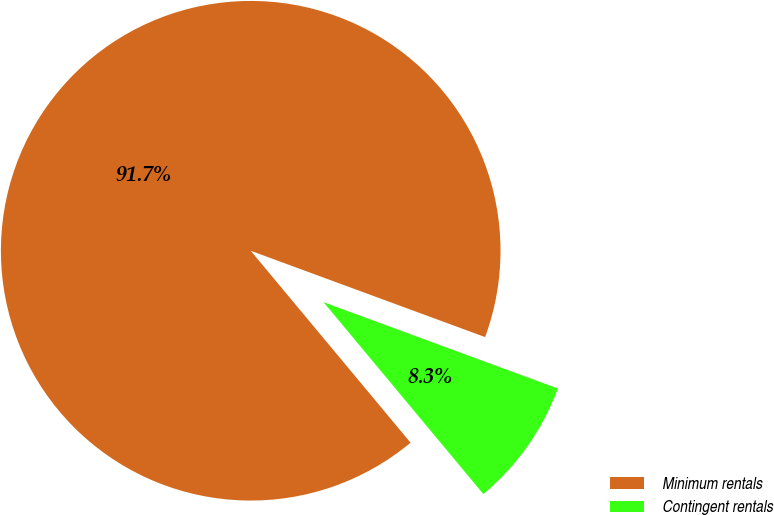Convert chart to OTSL. <chart><loc_0><loc_0><loc_500><loc_500><pie_chart><fcel>Minimum rentals<fcel>Contingent rentals<nl><fcel>91.67%<fcel>8.33%<nl></chart> 